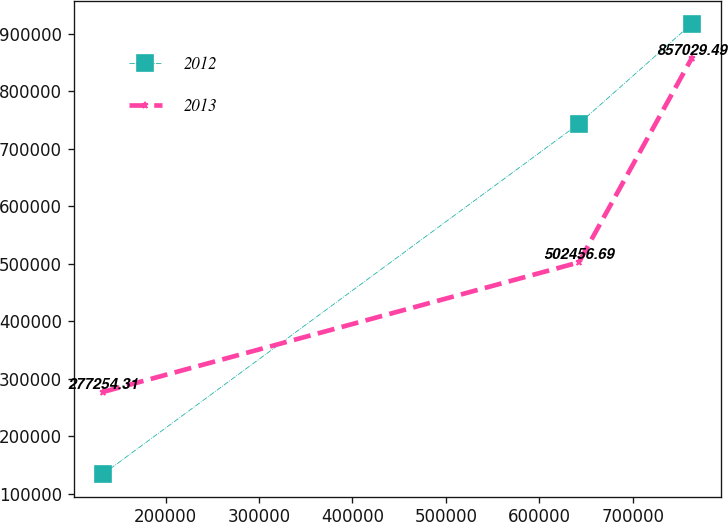Convert chart. <chart><loc_0><loc_0><loc_500><loc_500><line_chart><ecel><fcel>2012<fcel>2013<nl><fcel>132886<fcel>134461<fcel>277254<nl><fcel>642318<fcel>743301<fcel>502457<nl><fcel>763079<fcel>917093<fcel>857029<nl></chart> 